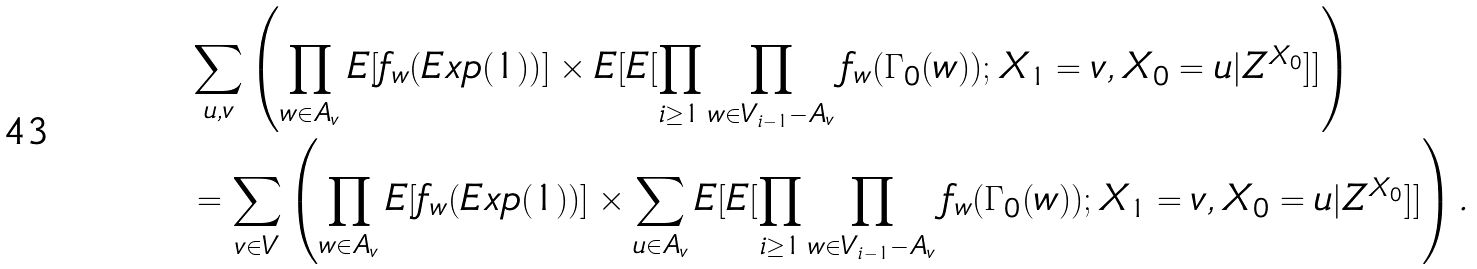Convert formula to latex. <formula><loc_0><loc_0><loc_500><loc_500>& \sum _ { u , v } \left ( \prod _ { w \in A _ { v } } E [ f _ { w } ( E x p ( 1 ) ) ] \times E [ E [ \prod _ { i \geq 1 } \prod _ { w \in V _ { i - 1 } - A _ { v } } f _ { w } ( \Gamma _ { 0 } ( w ) ) ; X _ { 1 } = v , X _ { 0 } = u | Z ^ { X _ { 0 } } ] ] \right ) \\ & = \sum _ { v \in V } \left ( \prod _ { w \in A _ { v } } E [ f _ { w } ( E x p ( 1 ) ) ] \times \sum _ { u \in A _ { v } } E [ E [ \prod _ { i \geq 1 } \prod _ { w \in V _ { i - 1 } - A _ { v } } f _ { w } ( \Gamma _ { 0 } ( w ) ) ; X _ { 1 } = v , X _ { 0 } = u | Z ^ { X _ { 0 } } ] ] \right ) .</formula> 